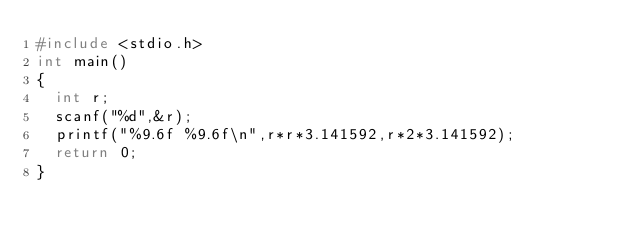Convert code to text. <code><loc_0><loc_0><loc_500><loc_500><_C_>#include <stdio.h>
int main()
{
  int r;
  scanf("%d",&r);
  printf("%9.6f %9.6f\n",r*r*3.141592,r*2*3.141592);
  return 0;
}</code> 